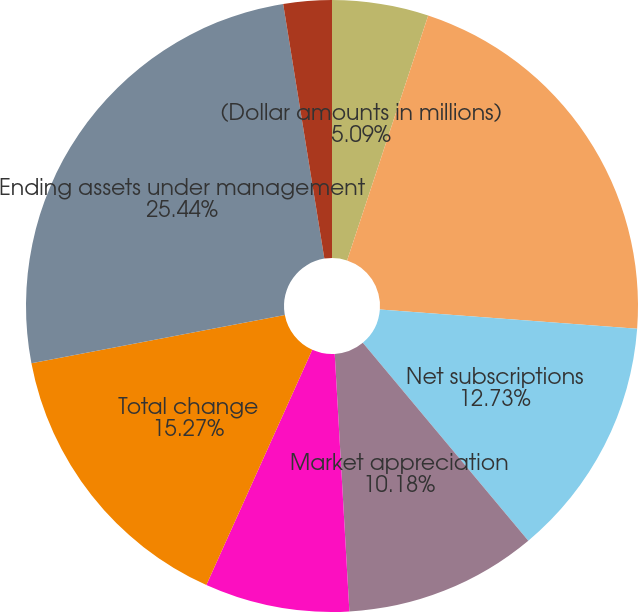Convert chart to OTSL. <chart><loc_0><loc_0><loc_500><loc_500><pie_chart><fcel>(Dollar amounts in millions)<fcel>Beginning assets under<fcel>Net subscriptions<fcel>Market appreciation<fcel>Foreign exchange (1)<fcel>Total change<fcel>Ending assets under management<fcel>Percent change in total AUM<fcel>Organic growth percentage<nl><fcel>5.09%<fcel>21.1%<fcel>12.73%<fcel>10.18%<fcel>7.64%<fcel>15.27%<fcel>25.45%<fcel>2.55%<fcel>0.0%<nl></chart> 